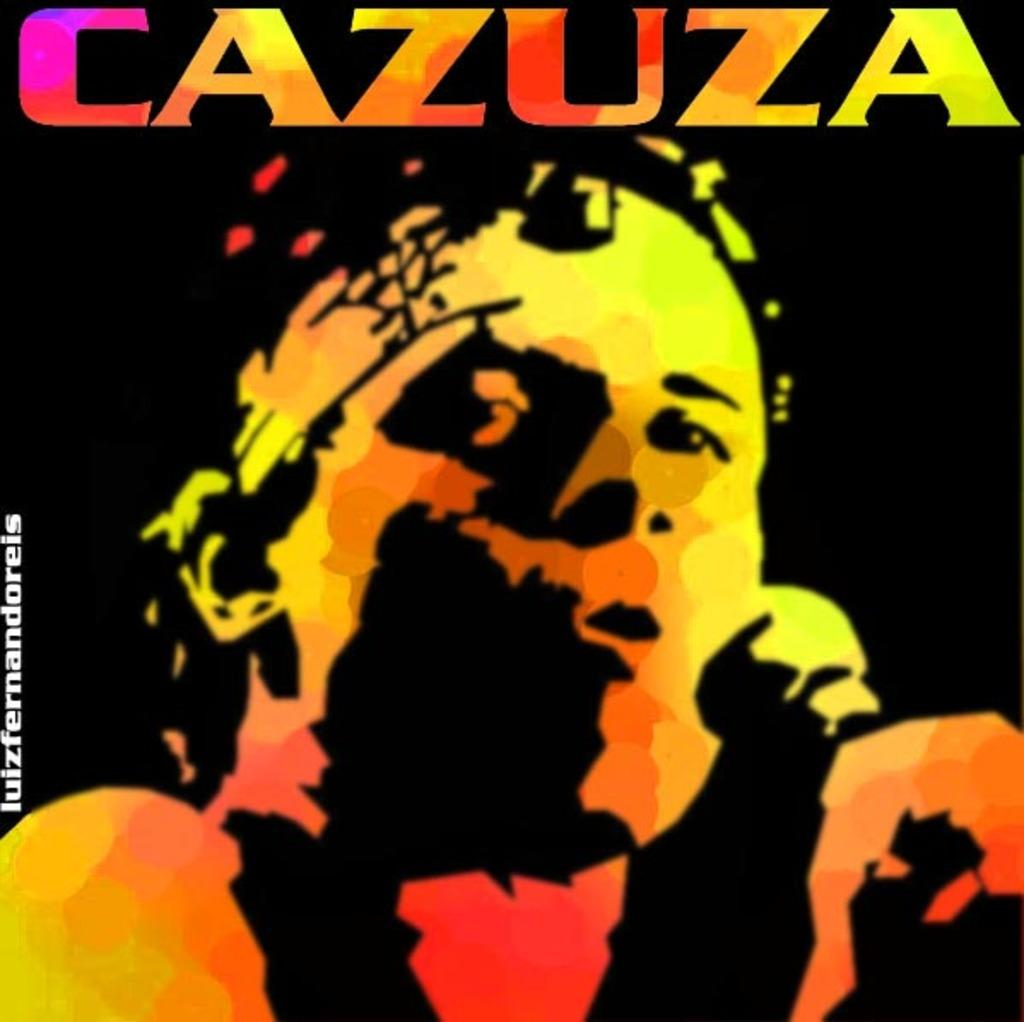<image>
Render a clear and concise summary of the photo. A man is singing into the microphone under the heading "Cazuza". 